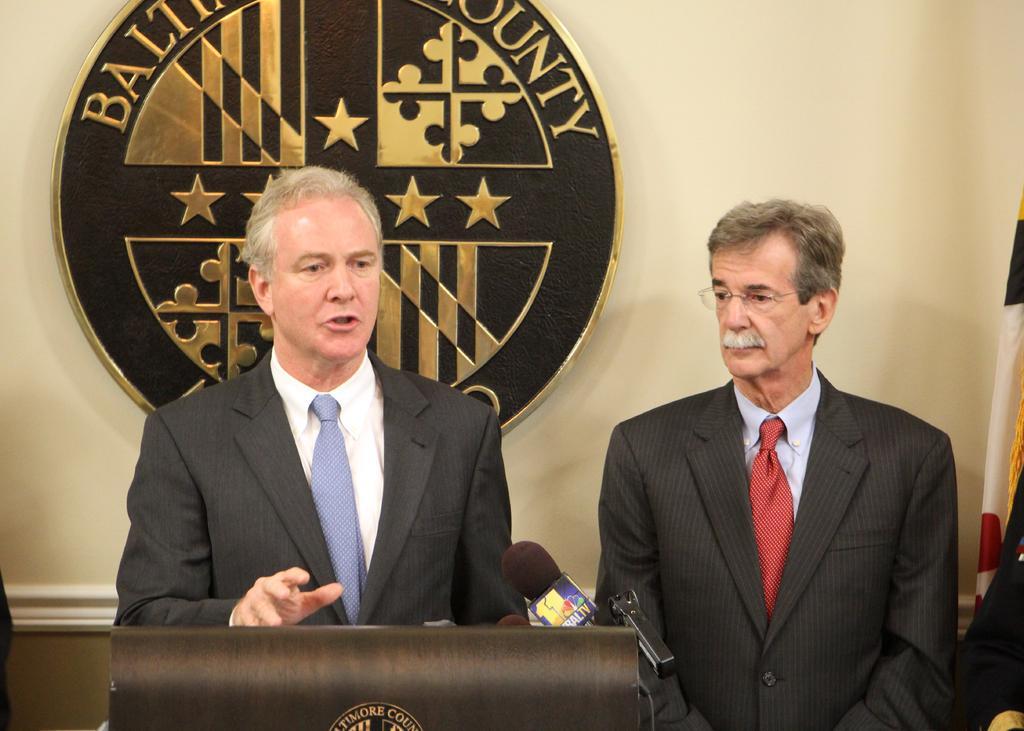Please provide a concise description of this image. In this picture we can see two men, a man on the left side is speaking something, there is a microphone in front of him, there is a logo and some text in the middle, we can see a wall in the background. 